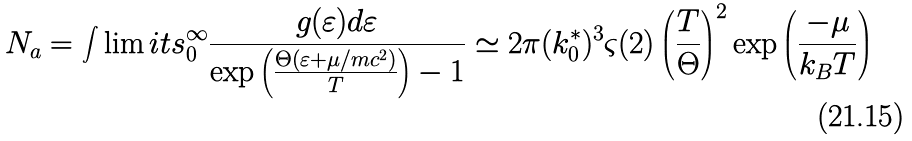<formula> <loc_0><loc_0><loc_500><loc_500>N _ { a } = \int \lim i t s _ { 0 } ^ { \infty } \frac { g ( \varepsilon ) d \varepsilon } { \exp \left ( \frac { \Theta ( \varepsilon + \mu / m c ^ { 2 } ) } T \right ) - 1 } \simeq 2 \pi ( k _ { 0 } ^ { * } ) ^ { 3 } \varsigma ( 2 ) \left ( \frac { T } { \Theta } \right ) ^ { 2 } \exp \left ( \frac { - \mu } { k _ { B } T } \right )</formula> 